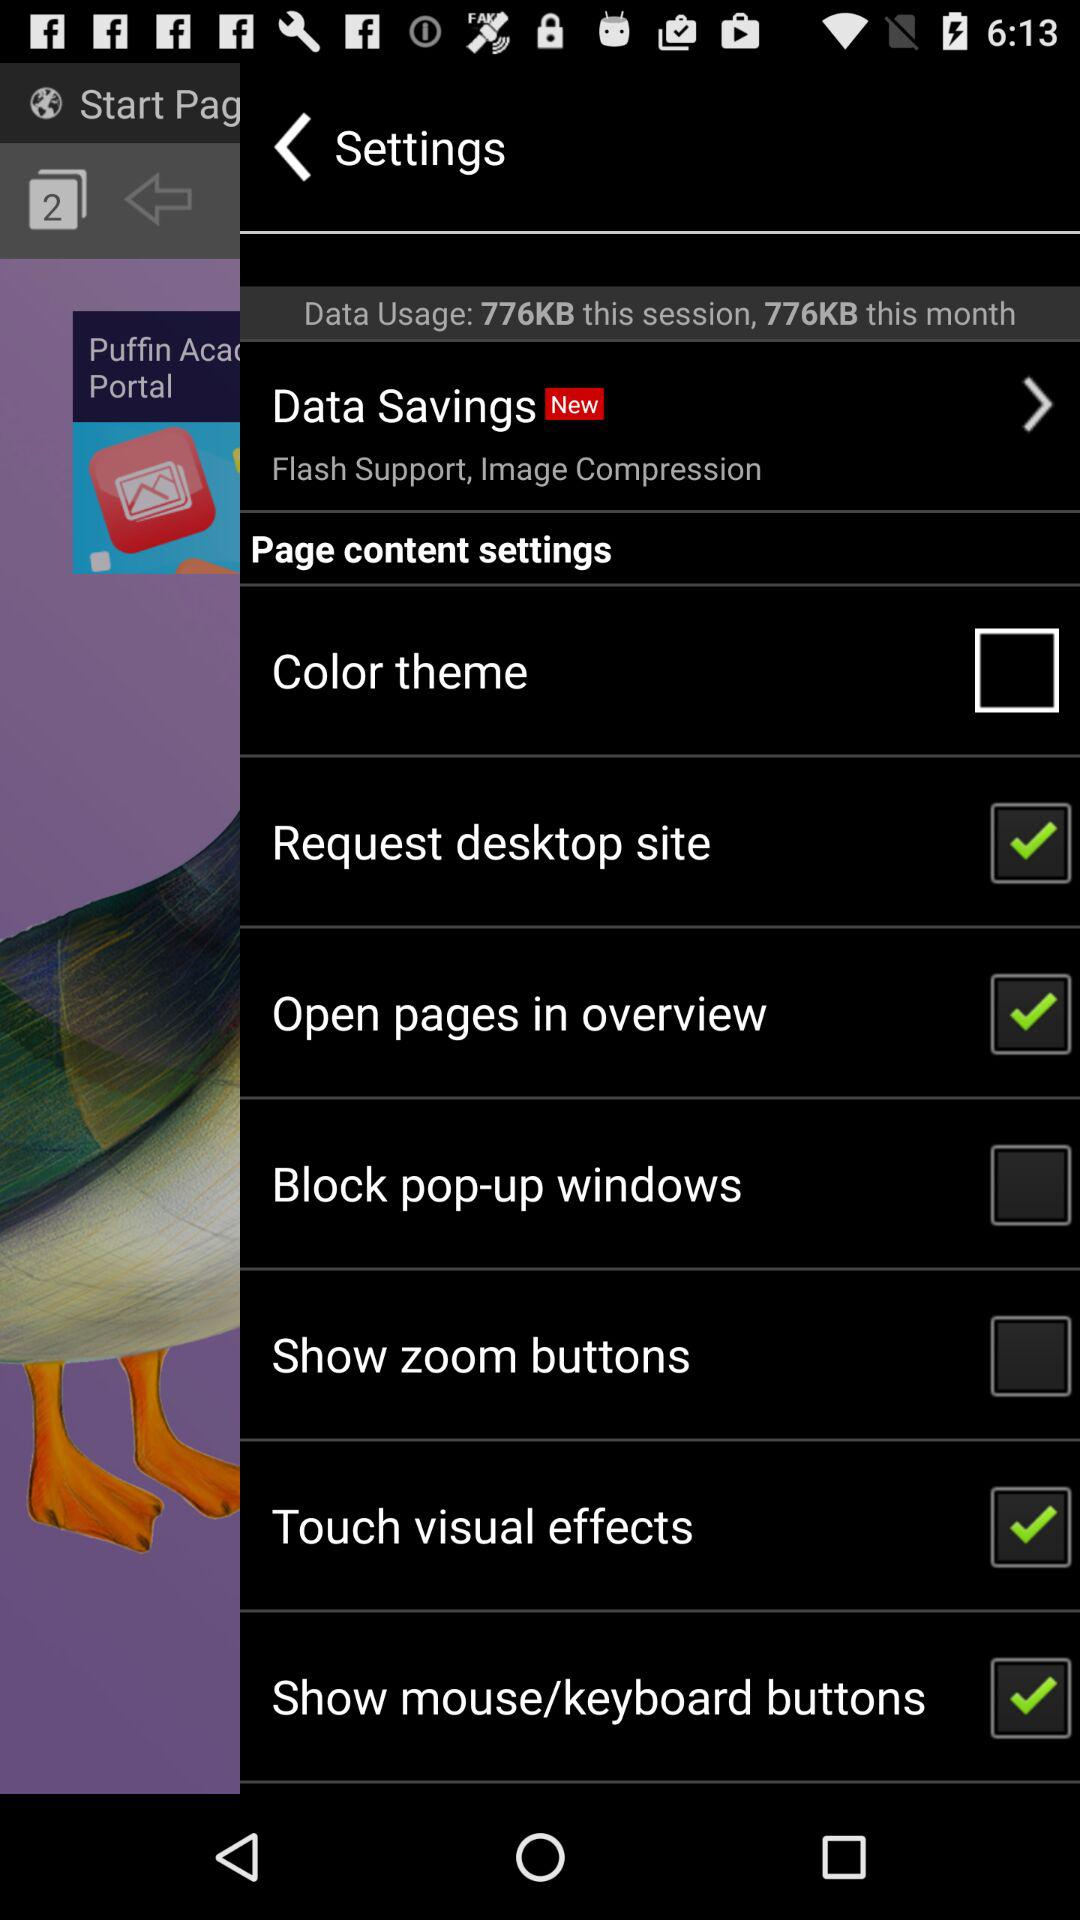How many tabs are open? There are 2 tabs open. 